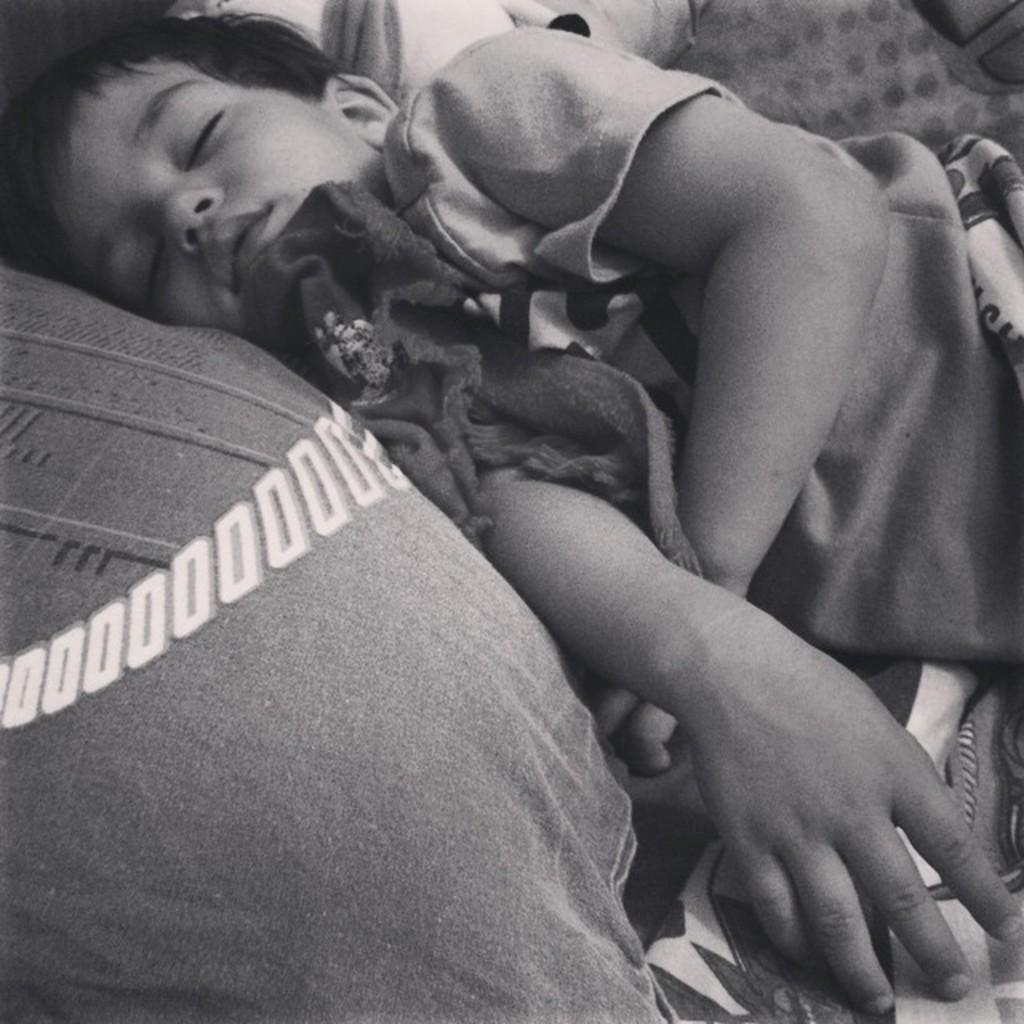Who is in the image? There is a boy in the image. What is the boy doing in the image? The boy is sleeping on the bed. What is beside the boy on the bed? There is a pillow beside the boy. What type of appliance can be seen in the image? There is no appliance present in the image. Does the boy in the image express any feelings of hate? The image does not convey any emotions or feelings, so it cannot be determined if the boy expresses any feelings of hate. 